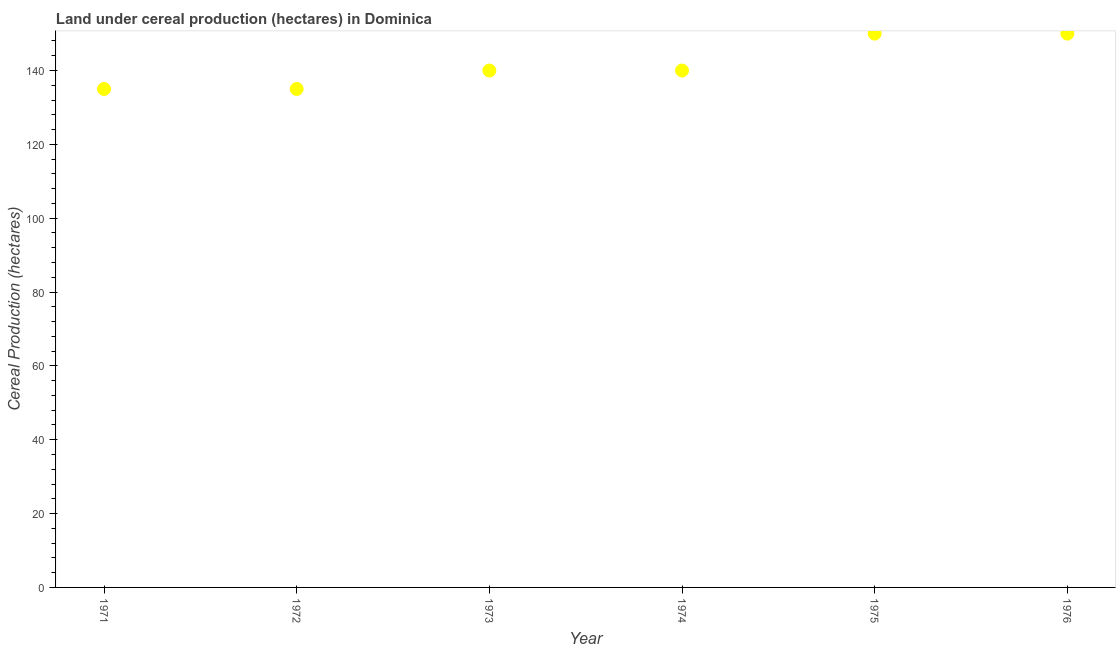What is the land under cereal production in 1973?
Your answer should be compact. 140. Across all years, what is the maximum land under cereal production?
Ensure brevity in your answer.  150. Across all years, what is the minimum land under cereal production?
Ensure brevity in your answer.  135. In which year was the land under cereal production maximum?
Give a very brief answer. 1975. What is the sum of the land under cereal production?
Ensure brevity in your answer.  850. What is the difference between the land under cereal production in 1975 and 1976?
Offer a very short reply. 0. What is the average land under cereal production per year?
Keep it short and to the point. 141.67. What is the median land under cereal production?
Your answer should be very brief. 140. In how many years, is the land under cereal production greater than 16 hectares?
Make the answer very short. 6. Do a majority of the years between 1976 and 1973 (inclusive) have land under cereal production greater than 92 hectares?
Your answer should be very brief. Yes. What is the ratio of the land under cereal production in 1971 to that in 1972?
Provide a short and direct response. 1. Is the land under cereal production in 1972 less than that in 1973?
Your answer should be very brief. Yes. Is the difference between the land under cereal production in 1971 and 1973 greater than the difference between any two years?
Make the answer very short. No. What is the difference between the highest and the lowest land under cereal production?
Your answer should be very brief. 15. Does the land under cereal production monotonically increase over the years?
Make the answer very short. No. Does the graph contain any zero values?
Your answer should be compact. No. Does the graph contain grids?
Ensure brevity in your answer.  No. What is the title of the graph?
Provide a short and direct response. Land under cereal production (hectares) in Dominica. What is the label or title of the X-axis?
Your answer should be compact. Year. What is the label or title of the Y-axis?
Your answer should be very brief. Cereal Production (hectares). What is the Cereal Production (hectares) in 1971?
Keep it short and to the point. 135. What is the Cereal Production (hectares) in 1972?
Offer a very short reply. 135. What is the Cereal Production (hectares) in 1973?
Offer a terse response. 140. What is the Cereal Production (hectares) in 1974?
Provide a short and direct response. 140. What is the Cereal Production (hectares) in 1975?
Keep it short and to the point. 150. What is the Cereal Production (hectares) in 1976?
Keep it short and to the point. 150. What is the difference between the Cereal Production (hectares) in 1971 and 1973?
Ensure brevity in your answer.  -5. What is the difference between the Cereal Production (hectares) in 1972 and 1973?
Your answer should be very brief. -5. What is the difference between the Cereal Production (hectares) in 1972 and 1974?
Provide a short and direct response. -5. What is the difference between the Cereal Production (hectares) in 1972 and 1975?
Give a very brief answer. -15. What is the difference between the Cereal Production (hectares) in 1973 and 1974?
Provide a short and direct response. 0. What is the difference between the Cereal Production (hectares) in 1973 and 1975?
Provide a succinct answer. -10. What is the difference between the Cereal Production (hectares) in 1974 and 1976?
Your answer should be very brief. -10. What is the ratio of the Cereal Production (hectares) in 1971 to that in 1972?
Your answer should be compact. 1. What is the ratio of the Cereal Production (hectares) in 1971 to that in 1973?
Your answer should be compact. 0.96. What is the ratio of the Cereal Production (hectares) in 1972 to that in 1973?
Offer a terse response. 0.96. What is the ratio of the Cereal Production (hectares) in 1972 to that in 1975?
Keep it short and to the point. 0.9. What is the ratio of the Cereal Production (hectares) in 1972 to that in 1976?
Your answer should be very brief. 0.9. What is the ratio of the Cereal Production (hectares) in 1973 to that in 1974?
Your response must be concise. 1. What is the ratio of the Cereal Production (hectares) in 1973 to that in 1975?
Your answer should be compact. 0.93. What is the ratio of the Cereal Production (hectares) in 1973 to that in 1976?
Make the answer very short. 0.93. What is the ratio of the Cereal Production (hectares) in 1974 to that in 1975?
Keep it short and to the point. 0.93. What is the ratio of the Cereal Production (hectares) in 1974 to that in 1976?
Your answer should be compact. 0.93. What is the ratio of the Cereal Production (hectares) in 1975 to that in 1976?
Keep it short and to the point. 1. 